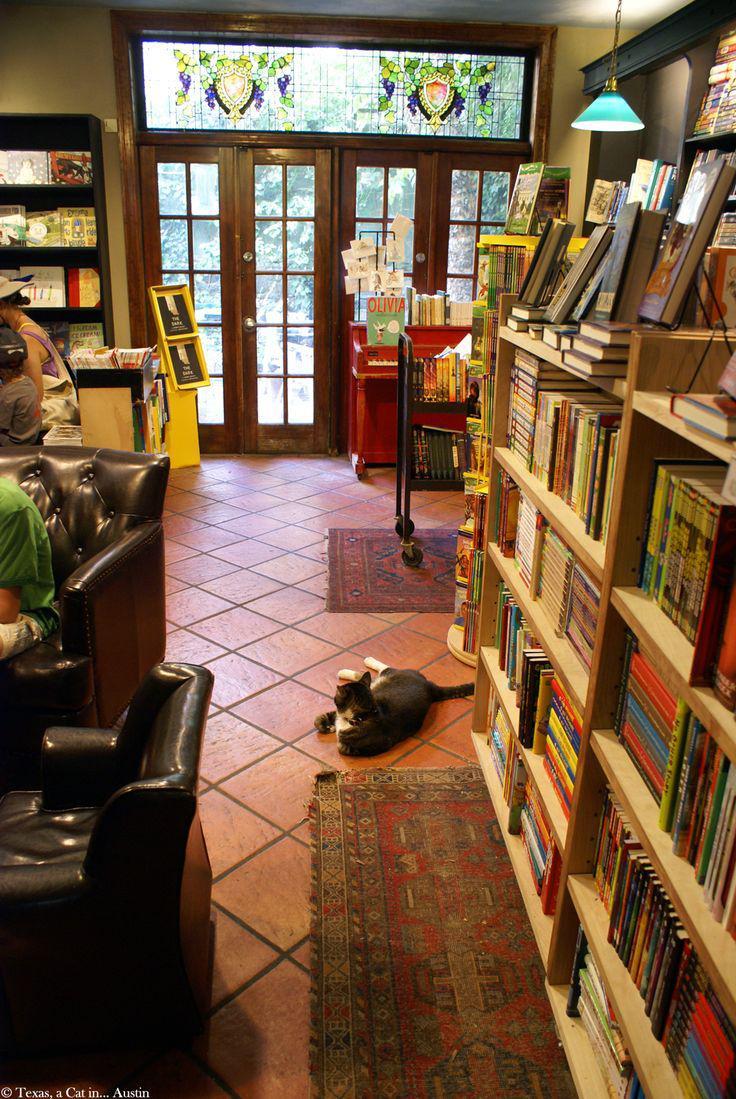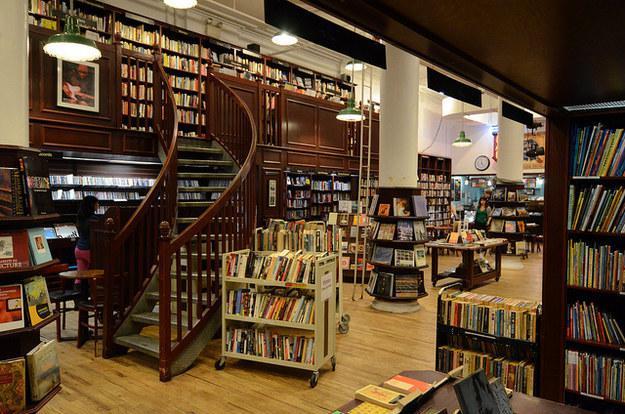The first image is the image on the left, the second image is the image on the right. For the images displayed, is the sentence "The front of the bookstore is painted green." factually correct? Answer yes or no. No. The first image is the image on the left, the second image is the image on the right. Assess this claim about the two images: "A bookstore has a curved staircase that leads to a higher floor.". Correct or not? Answer yes or no. Yes. 